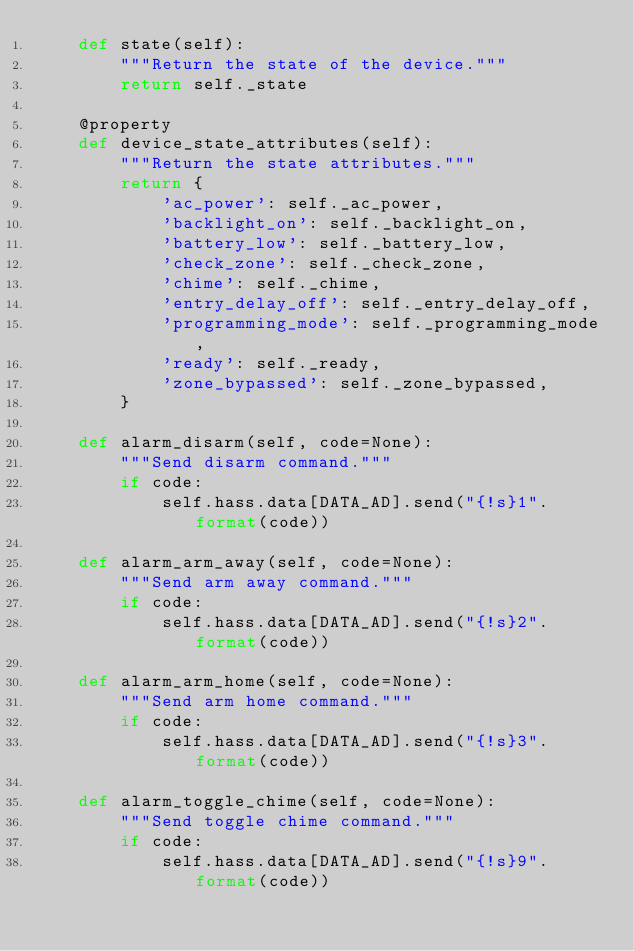Convert code to text. <code><loc_0><loc_0><loc_500><loc_500><_Python_>    def state(self):
        """Return the state of the device."""
        return self._state

    @property
    def device_state_attributes(self):
        """Return the state attributes."""
        return {
            'ac_power': self._ac_power,
            'backlight_on': self._backlight_on,
            'battery_low': self._battery_low,
            'check_zone': self._check_zone,
            'chime': self._chime,
            'entry_delay_off': self._entry_delay_off,
            'programming_mode': self._programming_mode,
            'ready': self._ready,
            'zone_bypassed': self._zone_bypassed,
        }

    def alarm_disarm(self, code=None):
        """Send disarm command."""
        if code:
            self.hass.data[DATA_AD].send("{!s}1".format(code))

    def alarm_arm_away(self, code=None):
        """Send arm away command."""
        if code:
            self.hass.data[DATA_AD].send("{!s}2".format(code))

    def alarm_arm_home(self, code=None):
        """Send arm home command."""
        if code:
            self.hass.data[DATA_AD].send("{!s}3".format(code))

    def alarm_toggle_chime(self, code=None):
        """Send toggle chime command."""
        if code:
            self.hass.data[DATA_AD].send("{!s}9".format(code))
</code> 